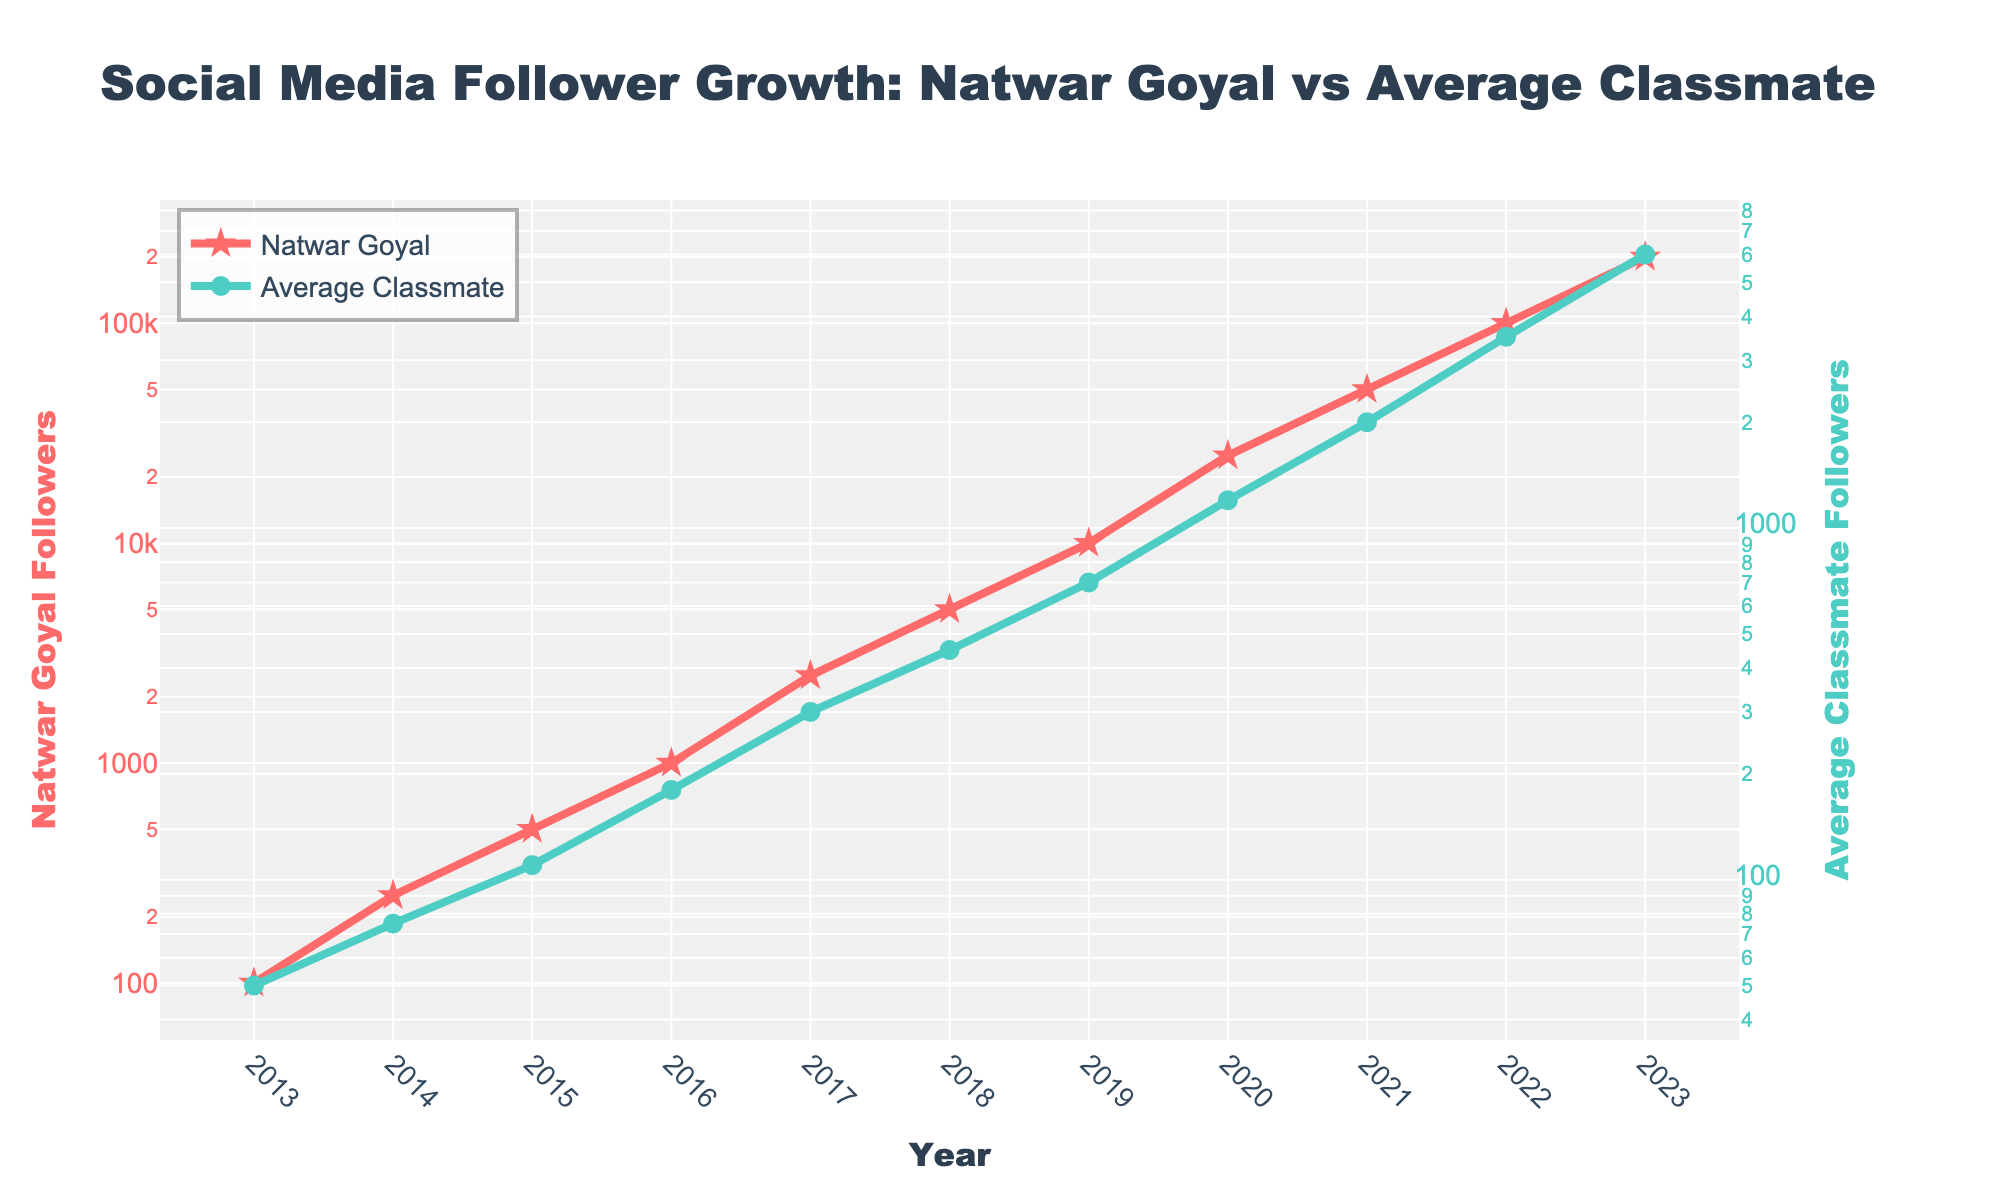What year did Natwar Goyal first surpass 1000 followers? In the chart, look for the point where Natwar Goyal's followers first exceed 1000. This happens between 2015 and 2016. Specifically, in 2016, Natwar Goyal's followers jumped to 1000.
Answer: 2016 What is the difference in followers between Natwar Goyal and the average classmate in 2023? To find this, subtract the average classmate's followers in 2023 from Natwar Goyal's followers in 2023. Natwar Goyal has 200,000 followers and the average classmate has 6000 followers. So, the difference is 200,000 - 6000 = 194,000.
Answer: 194,000 In which year did the average classmate surpass 1000 followers? Check the plot for the year when the average classmate's followers exceed 1000 for the first time. This occurs between 2019 and 2020. Specifically, in 2020, the average classmate's followers reached 1200.
Answer: 2020 How many times more followers did Natwar Goyal have than the average classmate in 2017? To find the multiple, divide Natwar Goyal's followers by the average classmate's followers for 2017. Natwar Goyal had 2500 followers, and the average classmate had 300 followers. So, 2500 / 300 = 8.33.
Answer: 8.33 What is the trend seen in Natwar Goyal's followers from 2013 to 2023? Observe the trend line of Natwar Goyal's followers. Natwar Goyal's followers increase exponentially over the years, showing a sharp upward trend from 2013 to 2023.
Answer: Exponential growth By how much did Natwar Goyal's followers increase from 2021 to 2022? Subtract the followers in 2021 from the followers in 2022. Natwar Goyal had 100,000 followers in 2022 and 50,000 followers in 2021. Therefore, the increase is 100,000 - 50,000 = 50,000.
Answer: 50,000 Between 2018 and 2019, how many more followers did Natwar Goyal gain compared to the average classmate? Calculate the difference in the increase of followers for both Natwar Goyal and the average classmate between 2018 and 2019. Natwar Goyal's followers increased by 10,000 - 5000 = 5000, and the average classmate's followers increased by 700 - 450 = 250. The difference is 5000 - 250 = 4750.
Answer: 4750 What visual element is used to mark Natwar Goyal's follower count in the plot? Look at the visual representation in the chart for Natwar Goyal. Natwar Goyal's follower count is marked with larger, red, star-shaped markers that also have a thicker line.
Answer: Red star-shaped markers Which year shows an "Explosive growth" annotation for Natwar Goyal's followers? Find the annotation in the chart. The annotation "Explosive growth!" is placed at the year 2023 for Natwar Goyal's followers.
Answer: 2023 